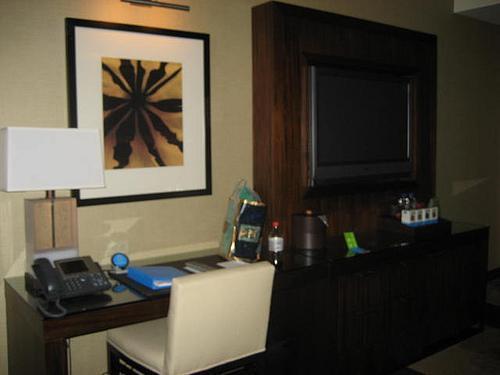How many lamps are in the room?
Give a very brief answer. 1. How many doors are there?
Give a very brief answer. 0. 